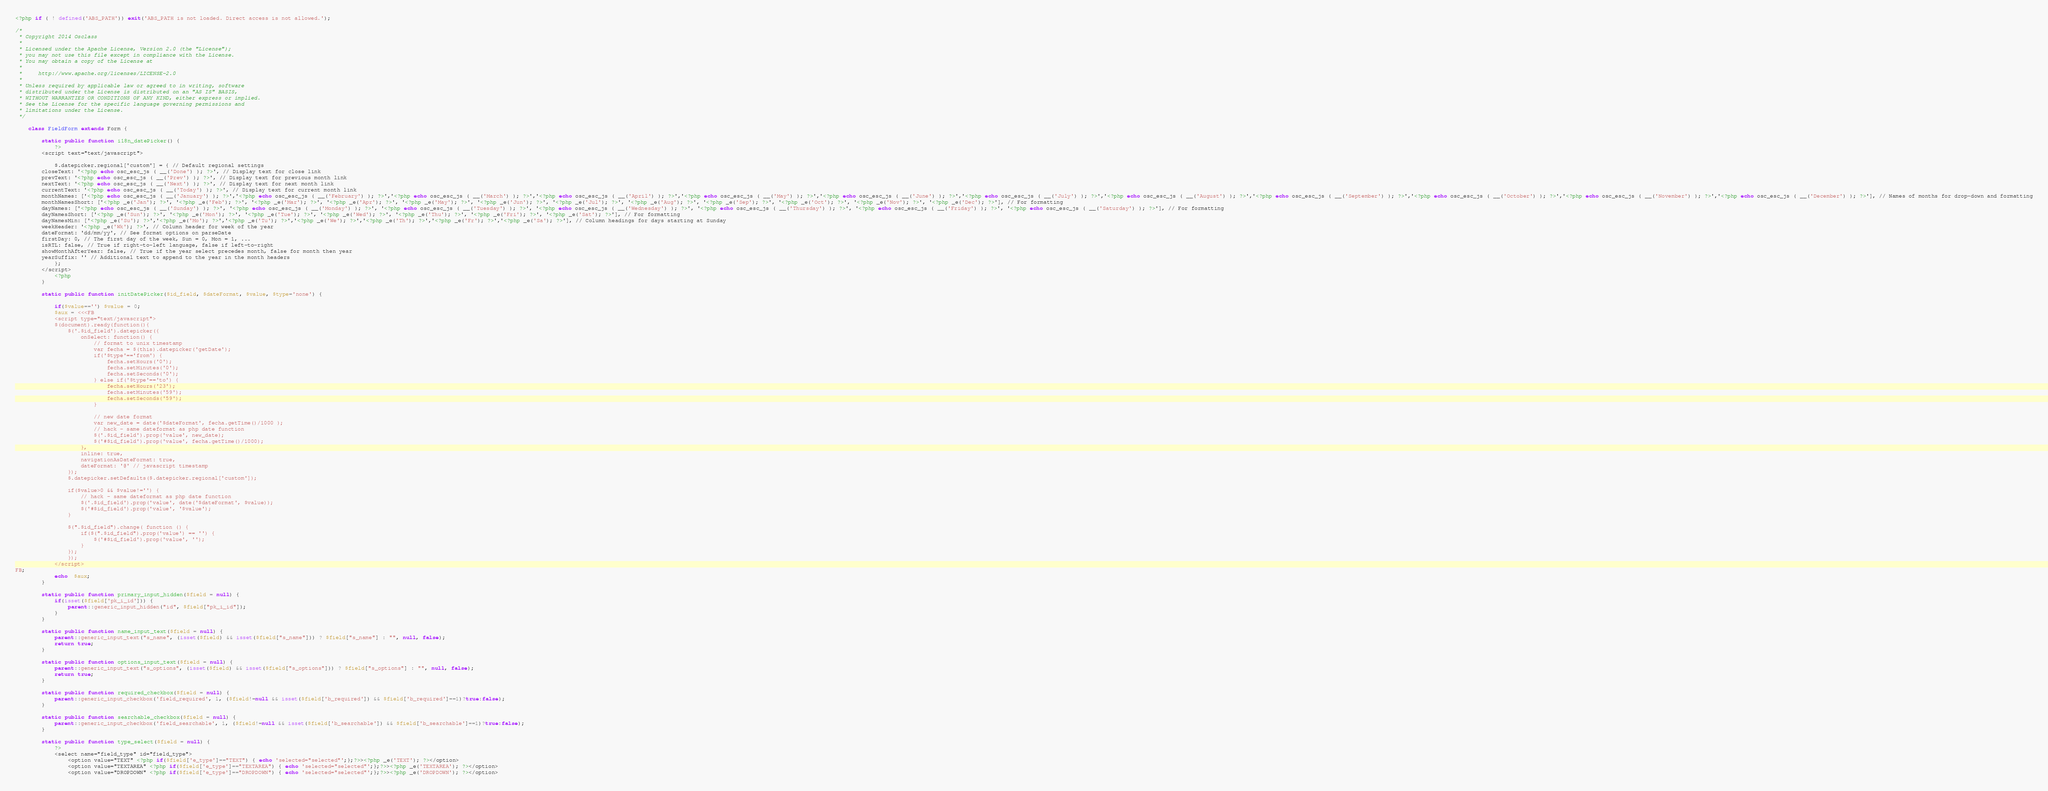<code> <loc_0><loc_0><loc_500><loc_500><_PHP_><?php if ( ! defined('ABS_PATH')) exit('ABS_PATH is not loaded. Direct access is not allowed.');

/*
 * Copyright 2014 Osclass
 *
 * Licensed under the Apache License, Version 2.0 (the "License");
 * you may not use this file except in compliance with the License.
 * You may obtain a copy of the License at
 *
 *     http://www.apache.org/licenses/LICENSE-2.0
 *
 * Unless required by applicable law or agreed to in writing, software
 * distributed under the License is distributed on an "AS IS" BASIS,
 * WITHOUT WARRANTIES OR CONDITIONS OF ANY KIND, either express or implied.
 * See the License for the specific language governing permissions and
 * limitations under the License.
 */

    class FieldForm extends Form {

        static public function i18n_datePicker() {
            ?>
        <script text="text/javascript">

            $.datepicker.regional['custom'] = { // Default regional settings
		closeText: '<?php echo osc_esc_js ( __('Done') ); ?>', // Display text for close link
		prevText: '<?php echo osc_esc_js ( __('Prev') ); ?>', // Display text for previous month link
		nextText: '<?php echo osc_esc_js ( __('Next') ); ?>', // Display text for next month link
		currentText: '<?php echo osc_esc_js ( __('Today') ); ?>', // Display text for current month link
		monthNames: ['<?php echo osc_esc_js ( __('January') ); ?>','<?php echo osc_esc_js ( __('February') ); ?>','<?php echo osc_esc_js ( __('March') ); ?>','<?php echo osc_esc_js ( __('April') ); ?>','<?php echo osc_esc_js ( __('May') ); ?>','<?php echo osc_esc_js ( __('June') ); ?>','<?php echo osc_esc_js ( __('July') ); ?>','<?php echo osc_esc_js ( __('August') ); ?>','<?php echo osc_esc_js ( __('September') ); ?>','<?php echo osc_esc_js ( __('October') ); ?>','<?php echo osc_esc_js ( __('November') ); ?>','<?php echo osc_esc_js ( __('December') ); ?>'], // Names of months for drop-down and formatting
		monthNamesShort: ['<?php _e('Jan'); ?>', '<?php _e('Feb'); ?>', '<?php _e('Mar'); ?>', '<?php _e('Apr'); ?>', '<?php _e('May'); ?>', '<?php _e('Jun'); ?>', '<?php _e('Jul'); ?>', '<?php _e('Aug'); ?>', '<?php _e('Sep'); ?>', '<?php _e('Oct'); ?>', '<?php _e('Nov'); ?>', '<?php _e('Dec'); ?>'], // For formatting
		dayNames: ['<?php echo osc_esc_js ( __('Sunday') ); ?>', '<?php echo osc_esc_js ( __('Monday') ); ?>', '<?php echo osc_esc_js ( __('Tuesday') ); ?>', '<?php echo osc_esc_js ( __('Wednesday') ); ?>', '<?php echo osc_esc_js ( __('Thursday') ); ?>', '<?php echo osc_esc_js ( __('Friday') ); ?>', '<?php echo osc_esc_js ( __('Saturday') ); ?>'], // For formatting
		dayNamesShort: ['<?php _e('Sun'); ?>', '<?php _e('Mon'); ?>', '<?php _e('Tue'); ?>', '<?php _e('Wed'); ?>', '<?php _e('Thu'); ?>', '<?php _e('Fri'); ?>', '<?php _e('Sat'); ?>'], // For formatting
		dayNamesMin: ['<?php _e('Su'); ?>','<?php _e('Mo'); ?>','<?php _e('Tu'); ?>','<?php _e('We'); ?>','<?php _e('Th'); ?>','<?php _e('Fr'); ?>','<?php _e('Sa'); ?>'], // Column headings for days starting at Sunday
		weekHeader: '<?php _e('Wk'); ?>', // Column header for week of the year
		dateFormat: 'dd/mm/yy', // See format options on parseDate
		firstDay: 0, // The first day of the week, Sun = 0, Mon = 1, ...
		isRTL: false, // True if right-to-left language, false if left-to-right
		showMonthAfterYear: false, // True if the year select precedes month, false for month then year
		yearSuffix: '' // Additional text to append to the year in the month headers
            };
        </script>
            <?php
        }

        static public function initDatePicker($id_field, $dateFormat, $value, $type='none') {

            if($value=='') $value = 0;
            $aux = <<<FB
            <script type="text/javascript">
            $(document).ready(function(){
                $('.$id_field').datepicker({
                    onSelect: function() {
                        // format to unix timestamp
                        var fecha = $(this).datepicker('getDate');
                        if('$type'=='from') {
                            fecha.setHours('0');
                            fecha.setMinutes('0');
                            fecha.setSeconds('0');
                        } else if('$type'=='to') {
                            fecha.setHours('23');
                            fecha.setMinutes('59');
                            fecha.setSeconds('59');
                        }

                        // new date format
                        var new_date = date('$dateFormat', fecha.getTime()/1000 );
                        // hack - same dateformat as php date function
                        $('.$id_field').prop('value', new_date);
                        $('#$id_field').prop('value', fecha.getTime()/1000);
                    },
                    inline: true,
                    navigationAsDateFormat: true,
                    dateFormat: '@' // javascript timestamp
                });
                $.datepicker.setDefaults($.datepicker.regional['custom']);

                if($value>0 && $value!='') {
                    // hack - same dateformat as php date function
                    $('.$id_field').prop('value', date('$dateFormat', $value));
                    $('#$id_field').prop('value', '$value');
                }

                $(".$id_field").change( function () {
                    if($(".$id_field").prop('value') == '') {
                        $('#$id_field').prop('value', '');
                    }
                });
                });
            </script>
FB;
            echo  $aux;
        }

        static public function primary_input_hidden($field = null) {
            if(isset($field['pk_i_id'])) {
                parent::generic_input_hidden("id", $field["pk_i_id"]);
            }
        }

        static public function name_input_text($field = null) {
            parent::generic_input_text("s_name", (isset($field) && isset($field["s_name"])) ? $field["s_name"] : "", null, false);
            return true;
        }

        static public function options_input_text($field = null) {
            parent::generic_input_text("s_options", (isset($field) && isset($field["s_options"])) ? $field["s_options"] : "", null, false);
            return true;
        }

        static public function required_checkbox($field = null) {
            parent::generic_input_checkbox('field_required', 1, ($field!=null && isset($field['b_required']) && $field['b_required']==1)?true:false);
        }

        static public function searchable_checkbox($field = null) {
            parent::generic_input_checkbox('field_searchable', 1, ($field!=null && isset($field['b_searchable']) && $field['b_searchable']==1)?true:false);
        }

        static public function type_select($field = null) {
            ?>
            <select name="field_type" id="field_type">
                <option value="TEXT" <?php if($field['e_type']=="TEXT") { echo 'selected="selected"';};?>><?php _e('TEXT'); ?></option>
                <option value="TEXTAREA" <?php if($field['e_type']=="TEXTAREA") { echo 'selected="selected"';};?>><?php _e('TEXTAREA'); ?></option>
                <option value="DROPDOWN" <?php if($field['e_type']=="DROPDOWN") { echo 'selected="selected"';};?>><?php _e('DROPDOWN'); ?></option></code> 